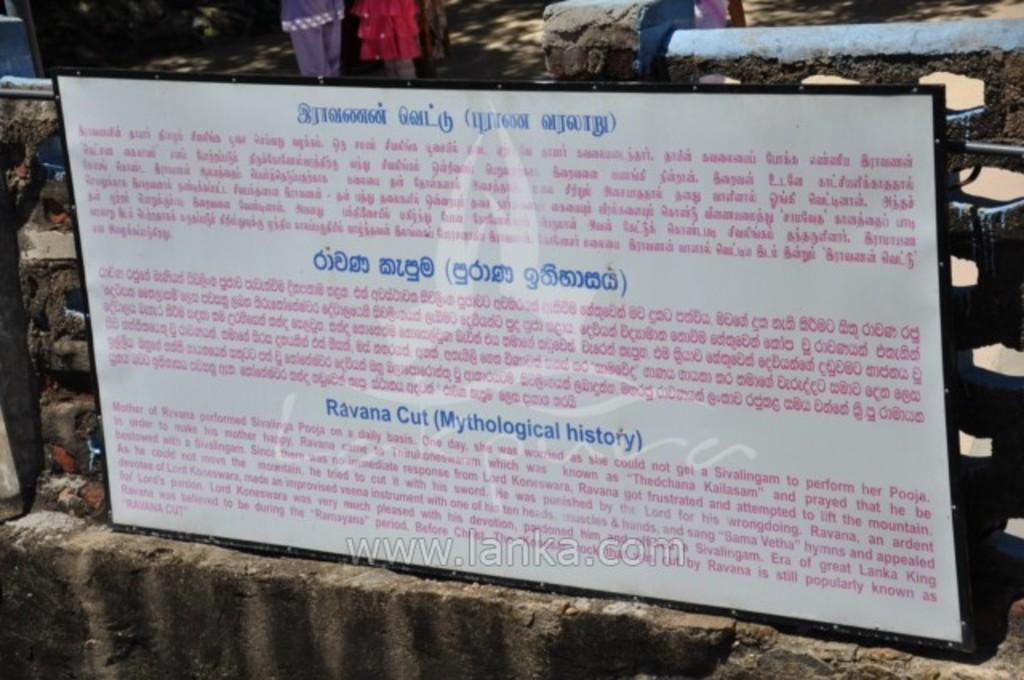What is the main object in the image? There is a board in the image. What can be seen on the board? There is a water mark on the board. Who is present in the image? There are people standing in the image. What are the people wearing? The people are wearing clothes. What other object can be seen in the image? There is a stone in the image. What type of lace can be seen on the people's clothing in the image? There is no lace visible on the people's clothing in the image. What type of lettuce is growing near the stone in the image? There is no lettuce present in the image; it only features a board, a water mark, people, their clothing, and a stone. 